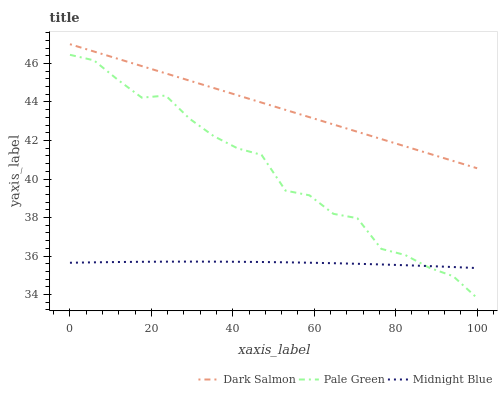Does Midnight Blue have the minimum area under the curve?
Answer yes or no. Yes. Does Dark Salmon have the maximum area under the curve?
Answer yes or no. Yes. Does Dark Salmon have the minimum area under the curve?
Answer yes or no. No. Does Midnight Blue have the maximum area under the curve?
Answer yes or no. No. Is Dark Salmon the smoothest?
Answer yes or no. Yes. Is Pale Green the roughest?
Answer yes or no. Yes. Is Midnight Blue the smoothest?
Answer yes or no. No. Is Midnight Blue the roughest?
Answer yes or no. No. Does Midnight Blue have the lowest value?
Answer yes or no. No. Does Midnight Blue have the highest value?
Answer yes or no. No. Is Pale Green less than Dark Salmon?
Answer yes or no. Yes. Is Dark Salmon greater than Midnight Blue?
Answer yes or no. Yes. Does Pale Green intersect Dark Salmon?
Answer yes or no. No. 